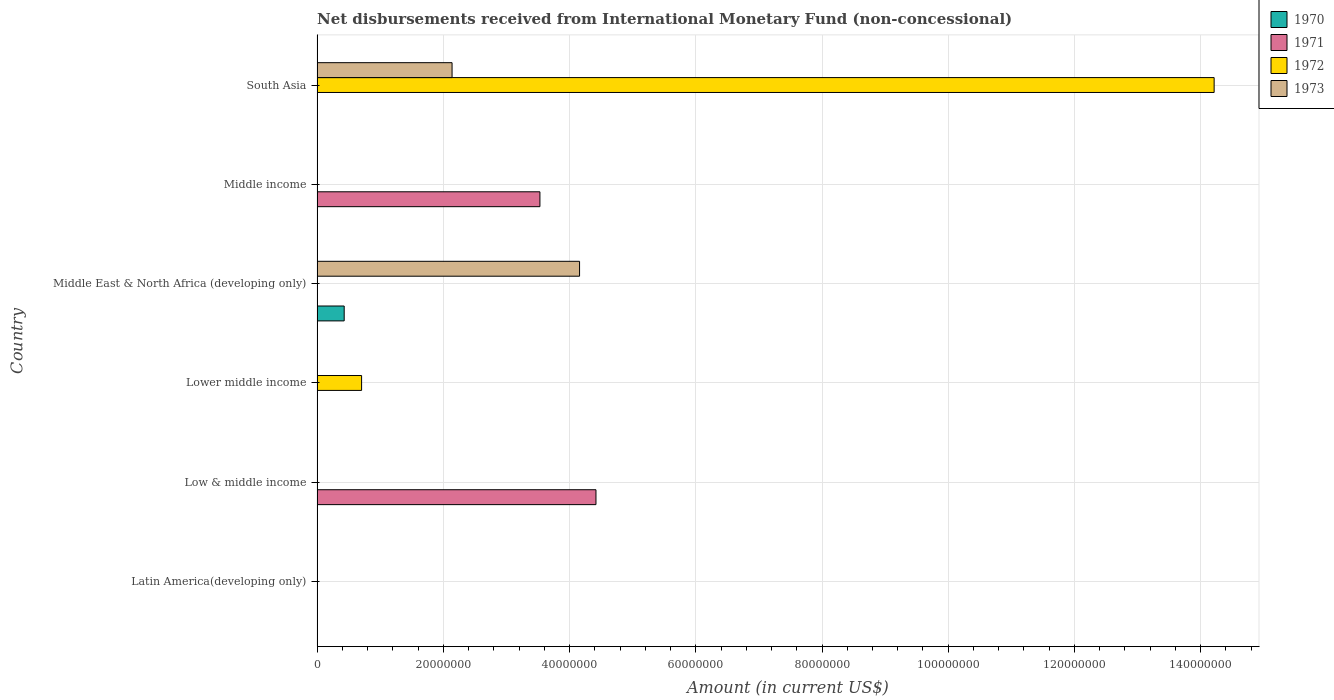How many different coloured bars are there?
Make the answer very short. 4. Are the number of bars on each tick of the Y-axis equal?
Your response must be concise. No. How many bars are there on the 3rd tick from the top?
Make the answer very short. 2. How many bars are there on the 6th tick from the bottom?
Keep it short and to the point. 2. What is the label of the 4th group of bars from the top?
Give a very brief answer. Lower middle income. What is the amount of disbursements received from International Monetary Fund in 1970 in Lower middle income?
Offer a terse response. 0. Across all countries, what is the maximum amount of disbursements received from International Monetary Fund in 1970?
Offer a very short reply. 4.30e+06. What is the total amount of disbursements received from International Monetary Fund in 1970 in the graph?
Your answer should be very brief. 4.30e+06. What is the difference between the amount of disbursements received from International Monetary Fund in 1973 in South Asia and the amount of disbursements received from International Monetary Fund in 1971 in Latin America(developing only)?
Ensure brevity in your answer.  2.14e+07. What is the average amount of disbursements received from International Monetary Fund in 1970 per country?
Keep it short and to the point. 7.17e+05. In how many countries, is the amount of disbursements received from International Monetary Fund in 1973 greater than 108000000 US$?
Keep it short and to the point. 0. What is the difference between the highest and the lowest amount of disbursements received from International Monetary Fund in 1972?
Provide a succinct answer. 1.42e+08. Is it the case that in every country, the sum of the amount of disbursements received from International Monetary Fund in 1970 and amount of disbursements received from International Monetary Fund in 1971 is greater than the amount of disbursements received from International Monetary Fund in 1972?
Offer a terse response. No. How many bars are there?
Provide a succinct answer. 7. Are all the bars in the graph horizontal?
Ensure brevity in your answer.  Yes. How many countries are there in the graph?
Offer a very short reply. 6. Are the values on the major ticks of X-axis written in scientific E-notation?
Give a very brief answer. No. What is the title of the graph?
Provide a succinct answer. Net disbursements received from International Monetary Fund (non-concessional). What is the label or title of the X-axis?
Offer a terse response. Amount (in current US$). What is the Amount (in current US$) in 1971 in Latin America(developing only)?
Your answer should be compact. 0. What is the Amount (in current US$) in 1972 in Latin America(developing only)?
Provide a short and direct response. 0. What is the Amount (in current US$) of 1971 in Low & middle income?
Provide a short and direct response. 4.42e+07. What is the Amount (in current US$) in 1972 in Low & middle income?
Offer a very short reply. 0. What is the Amount (in current US$) of 1970 in Lower middle income?
Offer a very short reply. 0. What is the Amount (in current US$) in 1972 in Lower middle income?
Offer a terse response. 7.06e+06. What is the Amount (in current US$) in 1973 in Lower middle income?
Make the answer very short. 0. What is the Amount (in current US$) of 1970 in Middle East & North Africa (developing only)?
Give a very brief answer. 4.30e+06. What is the Amount (in current US$) of 1973 in Middle East & North Africa (developing only)?
Your answer should be very brief. 4.16e+07. What is the Amount (in current US$) in 1970 in Middle income?
Your response must be concise. 0. What is the Amount (in current US$) of 1971 in Middle income?
Your response must be concise. 3.53e+07. What is the Amount (in current US$) of 1970 in South Asia?
Keep it short and to the point. 0. What is the Amount (in current US$) in 1972 in South Asia?
Ensure brevity in your answer.  1.42e+08. What is the Amount (in current US$) in 1973 in South Asia?
Provide a succinct answer. 2.14e+07. Across all countries, what is the maximum Amount (in current US$) of 1970?
Keep it short and to the point. 4.30e+06. Across all countries, what is the maximum Amount (in current US$) in 1971?
Give a very brief answer. 4.42e+07. Across all countries, what is the maximum Amount (in current US$) of 1972?
Make the answer very short. 1.42e+08. Across all countries, what is the maximum Amount (in current US$) in 1973?
Your response must be concise. 4.16e+07. Across all countries, what is the minimum Amount (in current US$) of 1972?
Make the answer very short. 0. What is the total Amount (in current US$) in 1970 in the graph?
Provide a succinct answer. 4.30e+06. What is the total Amount (in current US$) in 1971 in the graph?
Offer a very short reply. 7.95e+07. What is the total Amount (in current US$) of 1972 in the graph?
Provide a short and direct response. 1.49e+08. What is the total Amount (in current US$) in 1973 in the graph?
Make the answer very short. 6.30e+07. What is the difference between the Amount (in current US$) of 1971 in Low & middle income and that in Middle income?
Provide a succinct answer. 8.88e+06. What is the difference between the Amount (in current US$) of 1972 in Lower middle income and that in South Asia?
Your answer should be compact. -1.35e+08. What is the difference between the Amount (in current US$) of 1973 in Middle East & North Africa (developing only) and that in South Asia?
Your response must be concise. 2.02e+07. What is the difference between the Amount (in current US$) in 1971 in Low & middle income and the Amount (in current US$) in 1972 in Lower middle income?
Your answer should be very brief. 3.71e+07. What is the difference between the Amount (in current US$) of 1971 in Low & middle income and the Amount (in current US$) of 1973 in Middle East & North Africa (developing only)?
Ensure brevity in your answer.  2.60e+06. What is the difference between the Amount (in current US$) in 1971 in Low & middle income and the Amount (in current US$) in 1972 in South Asia?
Ensure brevity in your answer.  -9.79e+07. What is the difference between the Amount (in current US$) of 1971 in Low & middle income and the Amount (in current US$) of 1973 in South Asia?
Provide a short and direct response. 2.28e+07. What is the difference between the Amount (in current US$) in 1972 in Lower middle income and the Amount (in current US$) in 1973 in Middle East & North Africa (developing only)?
Make the answer very short. -3.45e+07. What is the difference between the Amount (in current US$) of 1972 in Lower middle income and the Amount (in current US$) of 1973 in South Asia?
Offer a very short reply. -1.43e+07. What is the difference between the Amount (in current US$) of 1970 in Middle East & North Africa (developing only) and the Amount (in current US$) of 1971 in Middle income?
Make the answer very short. -3.10e+07. What is the difference between the Amount (in current US$) of 1970 in Middle East & North Africa (developing only) and the Amount (in current US$) of 1972 in South Asia?
Keep it short and to the point. -1.38e+08. What is the difference between the Amount (in current US$) of 1970 in Middle East & North Africa (developing only) and the Amount (in current US$) of 1973 in South Asia?
Ensure brevity in your answer.  -1.71e+07. What is the difference between the Amount (in current US$) in 1971 in Middle income and the Amount (in current US$) in 1972 in South Asia?
Provide a short and direct response. -1.07e+08. What is the difference between the Amount (in current US$) in 1971 in Middle income and the Amount (in current US$) in 1973 in South Asia?
Offer a terse response. 1.39e+07. What is the average Amount (in current US$) of 1970 per country?
Your answer should be compact. 7.17e+05. What is the average Amount (in current US$) in 1971 per country?
Ensure brevity in your answer.  1.32e+07. What is the average Amount (in current US$) of 1972 per country?
Your response must be concise. 2.49e+07. What is the average Amount (in current US$) of 1973 per country?
Your answer should be very brief. 1.05e+07. What is the difference between the Amount (in current US$) in 1970 and Amount (in current US$) in 1973 in Middle East & North Africa (developing only)?
Provide a short and direct response. -3.73e+07. What is the difference between the Amount (in current US$) in 1972 and Amount (in current US$) in 1973 in South Asia?
Give a very brief answer. 1.21e+08. What is the ratio of the Amount (in current US$) in 1971 in Low & middle income to that in Middle income?
Give a very brief answer. 1.25. What is the ratio of the Amount (in current US$) of 1972 in Lower middle income to that in South Asia?
Your answer should be very brief. 0.05. What is the ratio of the Amount (in current US$) of 1973 in Middle East & North Africa (developing only) to that in South Asia?
Your response must be concise. 1.94. What is the difference between the highest and the lowest Amount (in current US$) of 1970?
Give a very brief answer. 4.30e+06. What is the difference between the highest and the lowest Amount (in current US$) in 1971?
Your answer should be very brief. 4.42e+07. What is the difference between the highest and the lowest Amount (in current US$) in 1972?
Your response must be concise. 1.42e+08. What is the difference between the highest and the lowest Amount (in current US$) in 1973?
Give a very brief answer. 4.16e+07. 